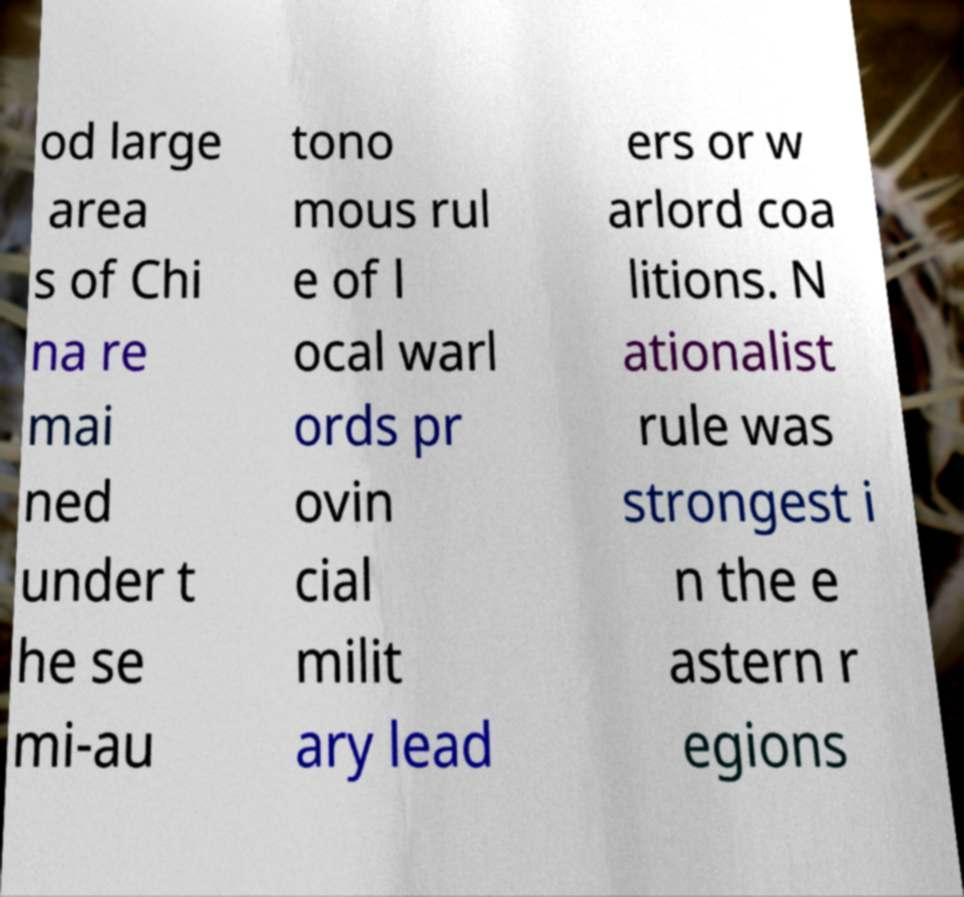What messages or text are displayed in this image? I need them in a readable, typed format. od large area s of Chi na re mai ned under t he se mi-au tono mous rul e of l ocal warl ords pr ovin cial milit ary lead ers or w arlord coa litions. N ationalist rule was strongest i n the e astern r egions 